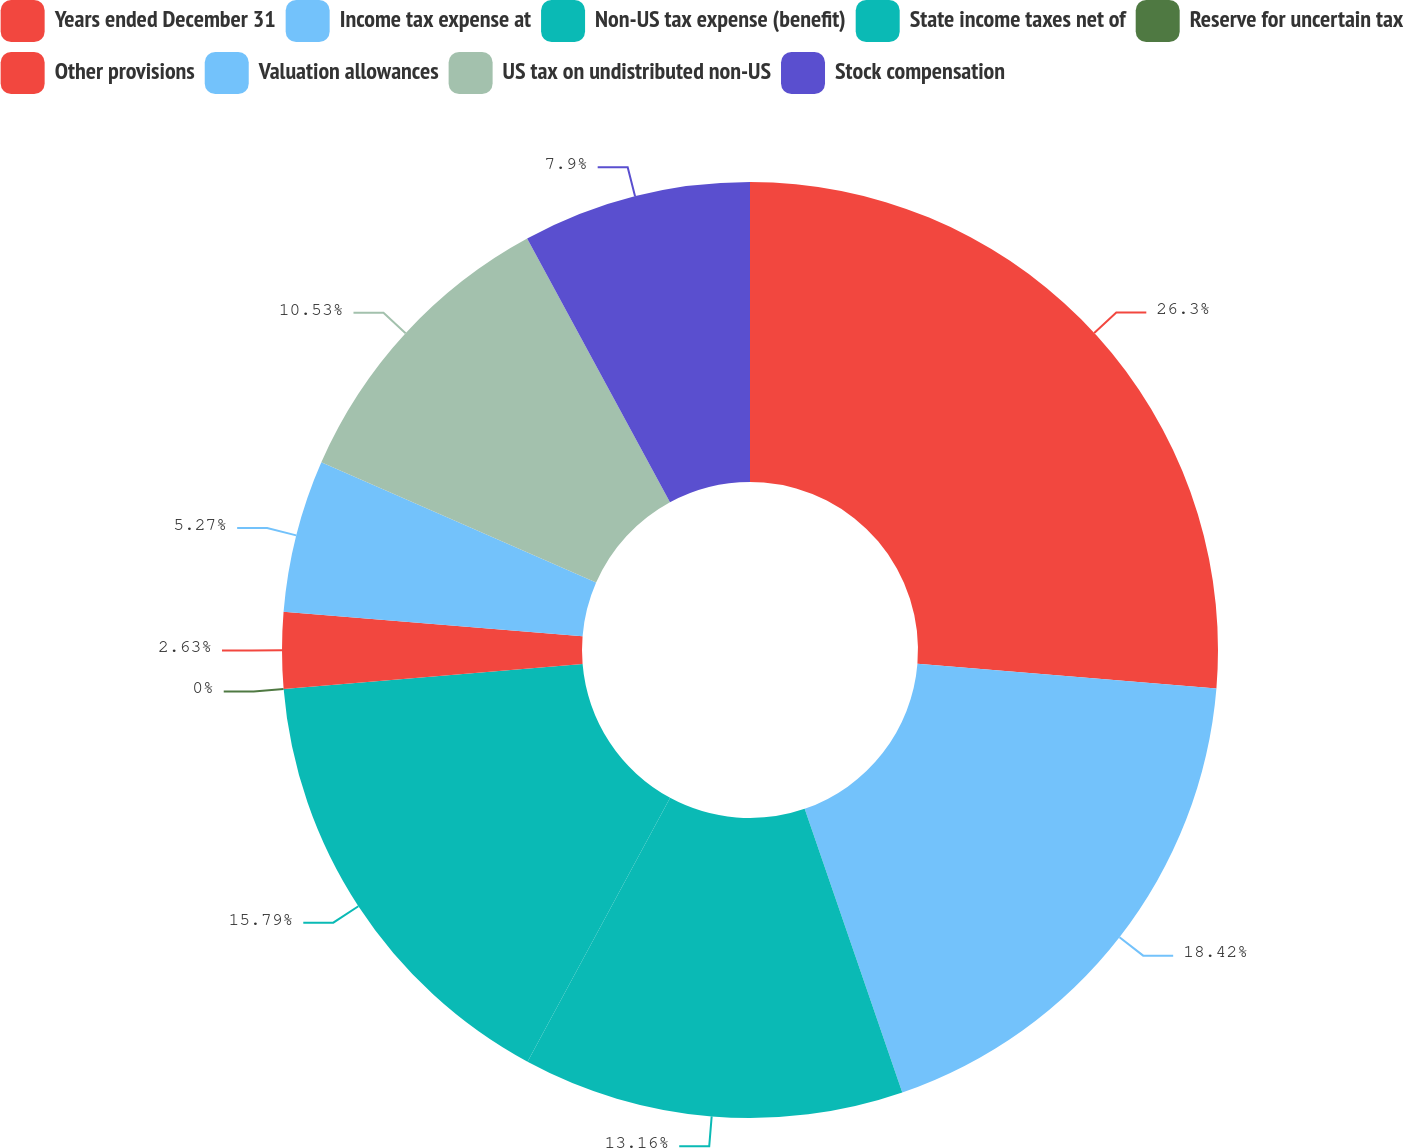Convert chart. <chart><loc_0><loc_0><loc_500><loc_500><pie_chart><fcel>Years ended December 31<fcel>Income tax expense at<fcel>Non-US tax expense (benefit)<fcel>State income taxes net of<fcel>Reserve for uncertain tax<fcel>Other provisions<fcel>Valuation allowances<fcel>US tax on undistributed non-US<fcel>Stock compensation<nl><fcel>26.31%<fcel>18.42%<fcel>13.16%<fcel>15.79%<fcel>0.0%<fcel>2.63%<fcel>5.27%<fcel>10.53%<fcel>7.9%<nl></chart> 